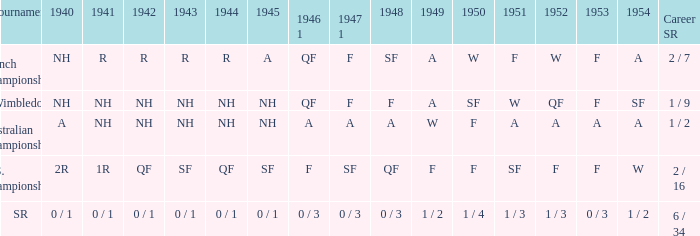Could you parse the entire table as a dict? {'header': ['Tournament', '1940', '1941', '1942', '1943', '1944', '1945', '1946 1', '1947 1', '1948', '1949', '1950', '1951', '1952', '1953', '1954', 'Career SR'], 'rows': [['French Championships', 'NH', 'R', 'R', 'R', 'R', 'A', 'QF', 'F', 'SF', 'A', 'W', 'F', 'W', 'F', 'A', '2 / 7'], ['Wimbledon', 'NH', 'NH', 'NH', 'NH', 'NH', 'NH', 'QF', 'F', 'F', 'A', 'SF', 'W', 'QF', 'F', 'SF', '1 / 9'], ['Australian Championships', 'A', 'NH', 'NH', 'NH', 'NH', 'NH', 'A', 'A', 'A', 'W', 'F', 'A', 'A', 'A', 'A', '1 / 2'], ['U.S. Championships', '2R', '1R', 'QF', 'SF', 'QF', 'SF', 'F', 'SF', 'QF', 'F', 'F', 'SF', 'F', 'F', 'W', '2 / 16'], ['SR', '0 / 1', '0 / 1', '0 / 1', '0 / 1', '0 / 1', '0 / 1', '0 / 3', '0 / 3', '0 / 3', '1 / 2', '1 / 4', '1 / 3', '1 / 3', '0 / 3', '1 / 2', '6 / 34']]} What is the tournament that had a result of A in 1954 and NH in 1942? Australian Championships. 